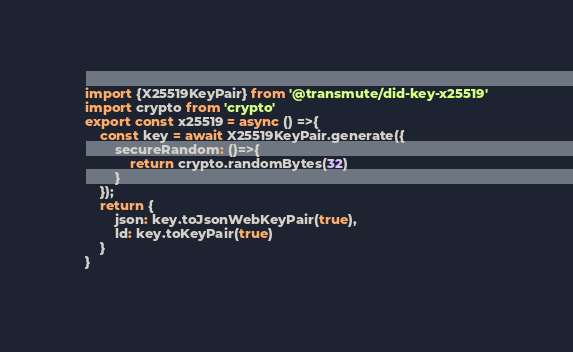Convert code to text. <code><loc_0><loc_0><loc_500><loc_500><_JavaScript_>import {X25519KeyPair} from '@transmute/did-key-x25519'
import crypto from 'crypto'
export const x25519 = async () =>{
    const key = await X25519KeyPair.generate({
        secureRandom: ()=>{
            return crypto.randomBytes(32)
        }
    });
    return {
        json: key.toJsonWebKeyPair(true),
        ld: key.toKeyPair(true)
    }
}</code> 